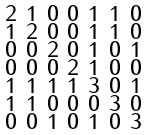Convert formula to latex. <formula><loc_0><loc_0><loc_500><loc_500>\begin{smallmatrix} 2 & 1 & 0 & 0 & 1 & 1 & 0 \\ 1 & 2 & 0 & 0 & 1 & 1 & 0 \\ 0 & 0 & 2 & 0 & 1 & 0 & 1 \\ 0 & 0 & 0 & 2 & 1 & 0 & 0 \\ 1 & 1 & 1 & 1 & 3 & 0 & 1 \\ 1 & 1 & 0 & 0 & 0 & 3 & 0 \\ 0 & 0 & 1 & 0 & 1 & 0 & 3 \end{smallmatrix}</formula> 